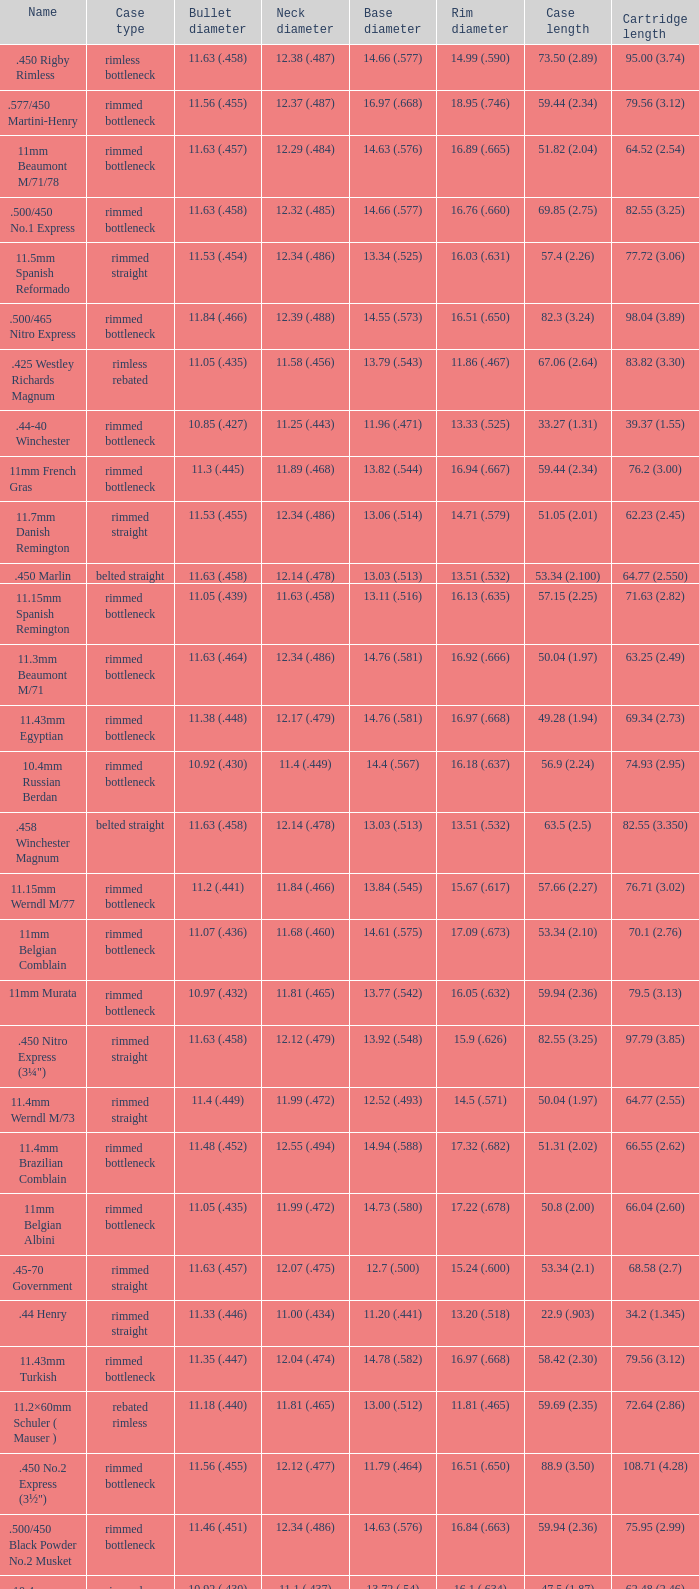Which Rim diameter has a Neck diameter of 11.84 (.466)? 15.67 (.617). 